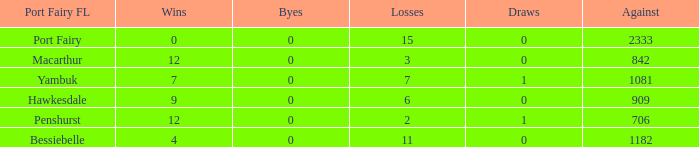For port fairy, how many wins exceed the count of 2333? None. 